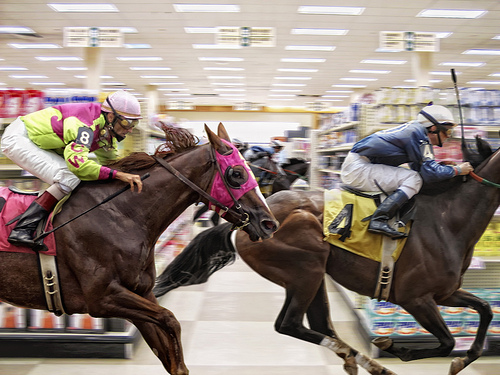<image>
Can you confirm if the race horse is in the store? Yes. The race horse is contained within or inside the store, showing a containment relationship. 